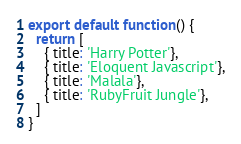<code> <loc_0><loc_0><loc_500><loc_500><_JavaScript_>export default function() {
  return [
    { title: 'Harry Potter'},
    { title: 'Eloquent Javascript'},
    { title: 'Malala'},
    { title: 'RubyFruit Jungle'},
  ]
}
</code> 